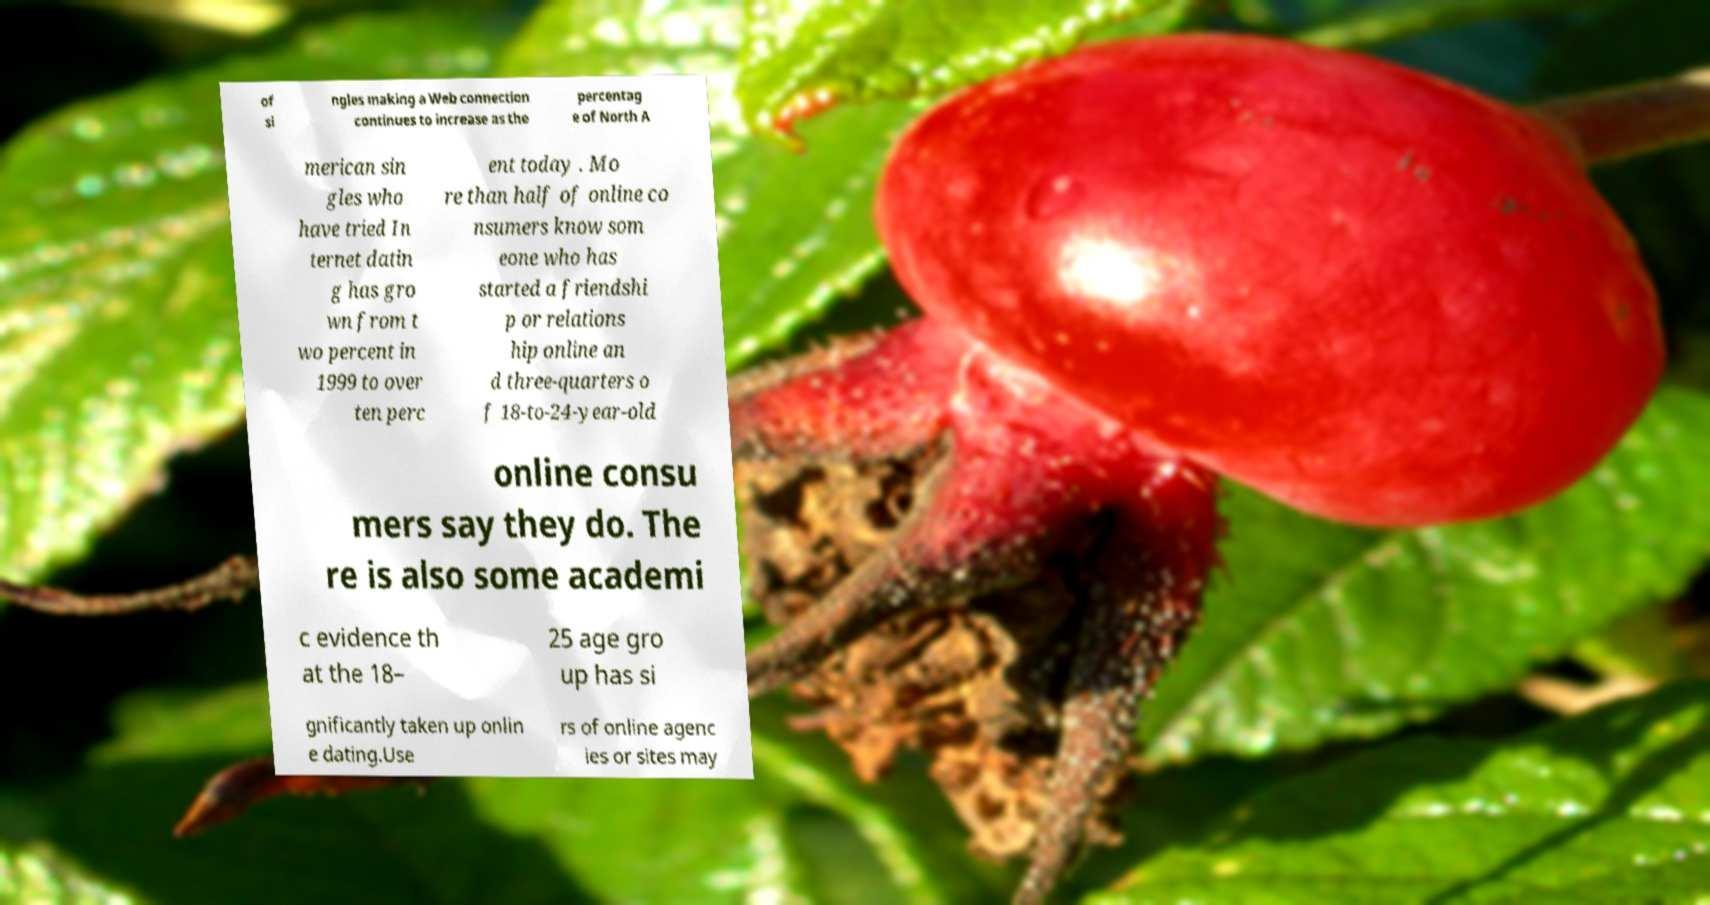Could you extract and type out the text from this image? of si ngles making a Web connection continues to increase as the percentag e of North A merican sin gles who have tried In ternet datin g has gro wn from t wo percent in 1999 to over ten perc ent today . Mo re than half of online co nsumers know som eone who has started a friendshi p or relations hip online an d three-quarters o f 18-to-24-year-old online consu mers say they do. The re is also some academi c evidence th at the 18– 25 age gro up has si gnificantly taken up onlin e dating.Use rs of online agenc ies or sites may 